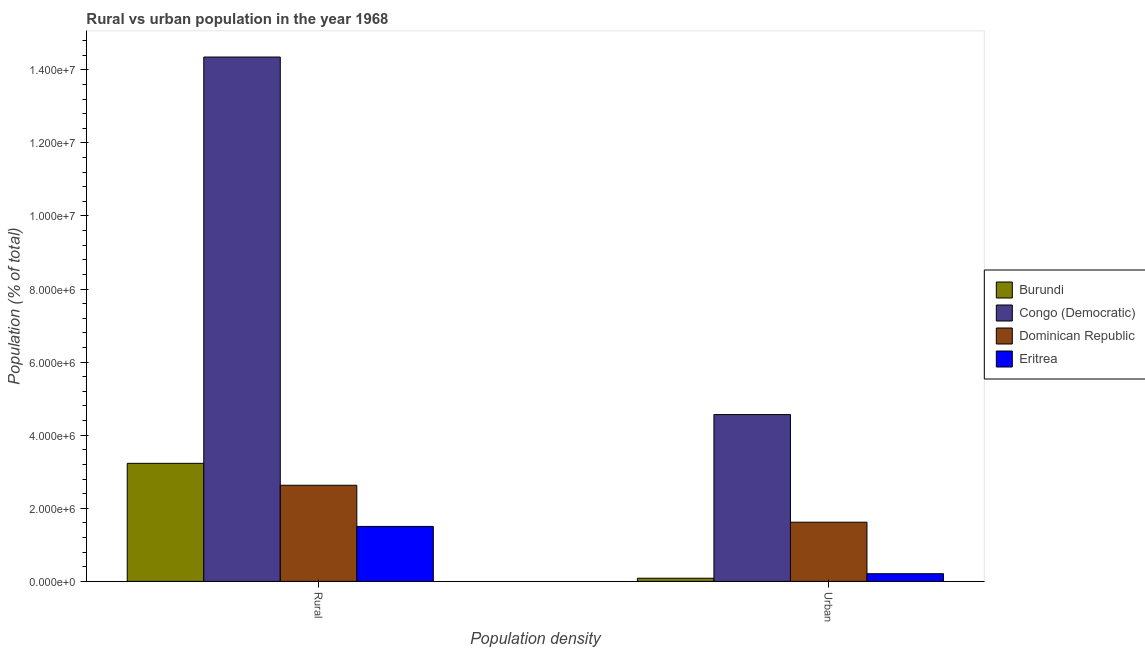How many groups of bars are there?
Your response must be concise. 2. How many bars are there on the 1st tick from the left?
Provide a short and direct response. 4. How many bars are there on the 2nd tick from the right?
Make the answer very short. 4. What is the label of the 1st group of bars from the left?
Ensure brevity in your answer.  Rural. What is the urban population density in Congo (Democratic)?
Provide a succinct answer. 4.56e+06. Across all countries, what is the maximum rural population density?
Provide a succinct answer. 1.43e+07. Across all countries, what is the minimum urban population density?
Give a very brief answer. 8.66e+04. In which country was the urban population density maximum?
Provide a short and direct response. Congo (Democratic). In which country was the urban population density minimum?
Your response must be concise. Burundi. What is the total rural population density in the graph?
Give a very brief answer. 2.17e+07. What is the difference between the urban population density in Burundi and that in Congo (Democratic)?
Offer a very short reply. -4.48e+06. What is the difference between the rural population density in Eritrea and the urban population density in Burundi?
Provide a succinct answer. 1.42e+06. What is the average rural population density per country?
Your answer should be very brief. 5.43e+06. What is the difference between the rural population density and urban population density in Burundi?
Offer a terse response. 3.14e+06. What is the ratio of the rural population density in Eritrea to that in Dominican Republic?
Give a very brief answer. 0.57. What does the 2nd bar from the left in Urban represents?
Your answer should be very brief. Congo (Democratic). What does the 1st bar from the right in Rural represents?
Your answer should be compact. Eritrea. Are all the bars in the graph horizontal?
Provide a succinct answer. No. How many countries are there in the graph?
Provide a short and direct response. 4. What is the difference between two consecutive major ticks on the Y-axis?
Provide a short and direct response. 2.00e+06. Are the values on the major ticks of Y-axis written in scientific E-notation?
Offer a very short reply. Yes. How are the legend labels stacked?
Keep it short and to the point. Vertical. What is the title of the graph?
Your response must be concise. Rural vs urban population in the year 1968. What is the label or title of the X-axis?
Make the answer very short. Population density. What is the label or title of the Y-axis?
Offer a terse response. Population (% of total). What is the Population (% of total) in Burundi in Rural?
Offer a terse response. 3.23e+06. What is the Population (% of total) in Congo (Democratic) in Rural?
Your response must be concise. 1.43e+07. What is the Population (% of total) of Dominican Republic in Rural?
Give a very brief answer. 2.63e+06. What is the Population (% of total) of Eritrea in Rural?
Provide a succinct answer. 1.50e+06. What is the Population (% of total) in Burundi in Urban?
Your answer should be very brief. 8.66e+04. What is the Population (% of total) of Congo (Democratic) in Urban?
Your answer should be very brief. 4.56e+06. What is the Population (% of total) of Dominican Republic in Urban?
Offer a very short reply. 1.62e+06. What is the Population (% of total) of Eritrea in Urban?
Offer a terse response. 2.10e+05. Across all Population density, what is the maximum Population (% of total) in Burundi?
Your response must be concise. 3.23e+06. Across all Population density, what is the maximum Population (% of total) in Congo (Democratic)?
Provide a succinct answer. 1.43e+07. Across all Population density, what is the maximum Population (% of total) in Dominican Republic?
Your answer should be compact. 2.63e+06. Across all Population density, what is the maximum Population (% of total) of Eritrea?
Your answer should be very brief. 1.50e+06. Across all Population density, what is the minimum Population (% of total) of Burundi?
Offer a very short reply. 8.66e+04. Across all Population density, what is the minimum Population (% of total) of Congo (Democratic)?
Give a very brief answer. 4.56e+06. Across all Population density, what is the minimum Population (% of total) in Dominican Republic?
Your response must be concise. 1.62e+06. Across all Population density, what is the minimum Population (% of total) in Eritrea?
Offer a very short reply. 2.10e+05. What is the total Population (% of total) in Burundi in the graph?
Provide a succinct answer. 3.32e+06. What is the total Population (% of total) in Congo (Democratic) in the graph?
Keep it short and to the point. 1.89e+07. What is the total Population (% of total) in Dominican Republic in the graph?
Offer a terse response. 4.25e+06. What is the total Population (% of total) of Eritrea in the graph?
Offer a very short reply. 1.71e+06. What is the difference between the Population (% of total) in Burundi in Rural and that in Urban?
Ensure brevity in your answer.  3.14e+06. What is the difference between the Population (% of total) in Congo (Democratic) in Rural and that in Urban?
Your answer should be very brief. 9.78e+06. What is the difference between the Population (% of total) in Dominican Republic in Rural and that in Urban?
Your response must be concise. 1.01e+06. What is the difference between the Population (% of total) in Eritrea in Rural and that in Urban?
Your response must be concise. 1.29e+06. What is the difference between the Population (% of total) in Burundi in Rural and the Population (% of total) in Congo (Democratic) in Urban?
Provide a succinct answer. -1.33e+06. What is the difference between the Population (% of total) in Burundi in Rural and the Population (% of total) in Dominican Republic in Urban?
Provide a short and direct response. 1.61e+06. What is the difference between the Population (% of total) of Burundi in Rural and the Population (% of total) of Eritrea in Urban?
Provide a short and direct response. 3.02e+06. What is the difference between the Population (% of total) in Congo (Democratic) in Rural and the Population (% of total) in Dominican Republic in Urban?
Provide a short and direct response. 1.27e+07. What is the difference between the Population (% of total) of Congo (Democratic) in Rural and the Population (% of total) of Eritrea in Urban?
Give a very brief answer. 1.41e+07. What is the difference between the Population (% of total) in Dominican Republic in Rural and the Population (% of total) in Eritrea in Urban?
Make the answer very short. 2.42e+06. What is the average Population (% of total) in Burundi per Population density?
Make the answer very short. 1.66e+06. What is the average Population (% of total) in Congo (Democratic) per Population density?
Make the answer very short. 9.46e+06. What is the average Population (% of total) in Dominican Republic per Population density?
Your response must be concise. 2.13e+06. What is the average Population (% of total) of Eritrea per Population density?
Offer a very short reply. 8.57e+05. What is the difference between the Population (% of total) in Burundi and Population (% of total) in Congo (Democratic) in Rural?
Your response must be concise. -1.11e+07. What is the difference between the Population (% of total) in Burundi and Population (% of total) in Dominican Republic in Rural?
Offer a very short reply. 6.00e+05. What is the difference between the Population (% of total) in Burundi and Population (% of total) in Eritrea in Rural?
Make the answer very short. 1.73e+06. What is the difference between the Population (% of total) of Congo (Democratic) and Population (% of total) of Dominican Republic in Rural?
Keep it short and to the point. 1.17e+07. What is the difference between the Population (% of total) in Congo (Democratic) and Population (% of total) in Eritrea in Rural?
Your response must be concise. 1.28e+07. What is the difference between the Population (% of total) of Dominican Republic and Population (% of total) of Eritrea in Rural?
Keep it short and to the point. 1.13e+06. What is the difference between the Population (% of total) of Burundi and Population (% of total) of Congo (Democratic) in Urban?
Make the answer very short. -4.48e+06. What is the difference between the Population (% of total) in Burundi and Population (% of total) in Dominican Republic in Urban?
Keep it short and to the point. -1.53e+06. What is the difference between the Population (% of total) of Burundi and Population (% of total) of Eritrea in Urban?
Your answer should be compact. -1.24e+05. What is the difference between the Population (% of total) of Congo (Democratic) and Population (% of total) of Dominican Republic in Urban?
Make the answer very short. 2.95e+06. What is the difference between the Population (% of total) in Congo (Democratic) and Population (% of total) in Eritrea in Urban?
Your answer should be very brief. 4.35e+06. What is the difference between the Population (% of total) in Dominican Republic and Population (% of total) in Eritrea in Urban?
Keep it short and to the point. 1.41e+06. What is the ratio of the Population (% of total) of Burundi in Rural to that in Urban?
Your answer should be compact. 37.3. What is the ratio of the Population (% of total) of Congo (Democratic) in Rural to that in Urban?
Give a very brief answer. 3.14. What is the ratio of the Population (% of total) in Dominican Republic in Rural to that in Urban?
Give a very brief answer. 1.62. What is the ratio of the Population (% of total) in Eritrea in Rural to that in Urban?
Your answer should be very brief. 7.15. What is the difference between the highest and the second highest Population (% of total) of Burundi?
Provide a succinct answer. 3.14e+06. What is the difference between the highest and the second highest Population (% of total) in Congo (Democratic)?
Ensure brevity in your answer.  9.78e+06. What is the difference between the highest and the second highest Population (% of total) in Dominican Republic?
Offer a very short reply. 1.01e+06. What is the difference between the highest and the second highest Population (% of total) in Eritrea?
Offer a terse response. 1.29e+06. What is the difference between the highest and the lowest Population (% of total) of Burundi?
Your response must be concise. 3.14e+06. What is the difference between the highest and the lowest Population (% of total) in Congo (Democratic)?
Keep it short and to the point. 9.78e+06. What is the difference between the highest and the lowest Population (% of total) in Dominican Republic?
Provide a short and direct response. 1.01e+06. What is the difference between the highest and the lowest Population (% of total) of Eritrea?
Ensure brevity in your answer.  1.29e+06. 